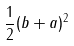Convert formula to latex. <formula><loc_0><loc_0><loc_500><loc_500>\frac { 1 } { 2 } ( b + a ) ^ { 2 }</formula> 